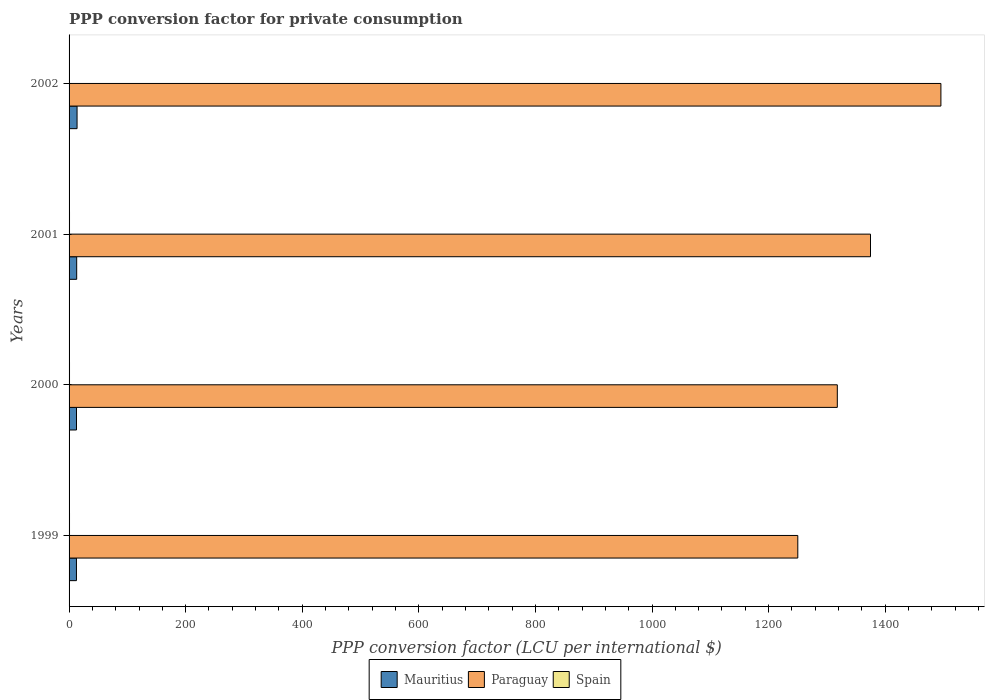How many different coloured bars are there?
Give a very brief answer. 3. Are the number of bars per tick equal to the number of legend labels?
Make the answer very short. Yes. How many bars are there on the 2nd tick from the top?
Ensure brevity in your answer.  3. How many bars are there on the 3rd tick from the bottom?
Your answer should be very brief. 3. What is the label of the 2nd group of bars from the top?
Provide a succinct answer. 2001. What is the PPP conversion factor for private consumption in Spain in 2001?
Your answer should be compact. 0.76. Across all years, what is the maximum PPP conversion factor for private consumption in Paraguay?
Provide a short and direct response. 1495.51. Across all years, what is the minimum PPP conversion factor for private consumption in Paraguay?
Provide a short and direct response. 1250.04. In which year was the PPP conversion factor for private consumption in Mauritius maximum?
Ensure brevity in your answer.  2002. What is the total PPP conversion factor for private consumption in Paraguay in the graph?
Provide a short and direct response. 5438.1. What is the difference between the PPP conversion factor for private consumption in Mauritius in 2000 and that in 2002?
Offer a terse response. -0.94. What is the difference between the PPP conversion factor for private consumption in Paraguay in 1999 and the PPP conversion factor for private consumption in Mauritius in 2002?
Offer a very short reply. 1236.34. What is the average PPP conversion factor for private consumption in Spain per year?
Offer a terse response. 0.76. In the year 1999, what is the difference between the PPP conversion factor for private consumption in Spain and PPP conversion factor for private consumption in Paraguay?
Ensure brevity in your answer.  -1249.27. What is the ratio of the PPP conversion factor for private consumption in Mauritius in 2000 to that in 2001?
Give a very brief answer. 0.98. Is the PPP conversion factor for private consumption in Spain in 1999 less than that in 2001?
Your answer should be compact. No. What is the difference between the highest and the second highest PPP conversion factor for private consumption in Spain?
Provide a short and direct response. 0. What is the difference between the highest and the lowest PPP conversion factor for private consumption in Spain?
Your answer should be compact. 0.02. In how many years, is the PPP conversion factor for private consumption in Spain greater than the average PPP conversion factor for private consumption in Spain taken over all years?
Offer a very short reply. 2. Is the sum of the PPP conversion factor for private consumption in Spain in 2001 and 2002 greater than the maximum PPP conversion factor for private consumption in Mauritius across all years?
Offer a terse response. No. What does the 3rd bar from the top in 2000 represents?
Ensure brevity in your answer.  Mauritius. What does the 2nd bar from the bottom in 2000 represents?
Your answer should be very brief. Paraguay. Is it the case that in every year, the sum of the PPP conversion factor for private consumption in Paraguay and PPP conversion factor for private consumption in Spain is greater than the PPP conversion factor for private consumption in Mauritius?
Your response must be concise. Yes. What is the difference between two consecutive major ticks on the X-axis?
Provide a short and direct response. 200. Are the values on the major ticks of X-axis written in scientific E-notation?
Give a very brief answer. No. How many legend labels are there?
Your answer should be compact. 3. How are the legend labels stacked?
Keep it short and to the point. Horizontal. What is the title of the graph?
Make the answer very short. PPP conversion factor for private consumption. Does "Bulgaria" appear as one of the legend labels in the graph?
Your answer should be compact. No. What is the label or title of the X-axis?
Make the answer very short. PPP conversion factor (LCU per international $). What is the PPP conversion factor (LCU per international $) in Mauritius in 1999?
Give a very brief answer. 12.65. What is the PPP conversion factor (LCU per international $) of Paraguay in 1999?
Offer a terse response. 1250.04. What is the PPP conversion factor (LCU per international $) in Spain in 1999?
Provide a short and direct response. 0.76. What is the PPP conversion factor (LCU per international $) of Mauritius in 2000?
Your response must be concise. 12.75. What is the PPP conversion factor (LCU per international $) in Paraguay in 2000?
Provide a succinct answer. 1317.81. What is the PPP conversion factor (LCU per international $) of Spain in 2000?
Your response must be concise. 0.76. What is the PPP conversion factor (LCU per international $) in Mauritius in 2001?
Ensure brevity in your answer.  13.07. What is the PPP conversion factor (LCU per international $) in Paraguay in 2001?
Provide a short and direct response. 1374.74. What is the PPP conversion factor (LCU per international $) in Spain in 2001?
Ensure brevity in your answer.  0.76. What is the PPP conversion factor (LCU per international $) in Mauritius in 2002?
Provide a short and direct response. 13.7. What is the PPP conversion factor (LCU per international $) in Paraguay in 2002?
Ensure brevity in your answer.  1495.51. What is the PPP conversion factor (LCU per international $) in Spain in 2002?
Ensure brevity in your answer.  0.75. Across all years, what is the maximum PPP conversion factor (LCU per international $) in Mauritius?
Make the answer very short. 13.7. Across all years, what is the maximum PPP conversion factor (LCU per international $) of Paraguay?
Your response must be concise. 1495.51. Across all years, what is the maximum PPP conversion factor (LCU per international $) of Spain?
Ensure brevity in your answer.  0.76. Across all years, what is the minimum PPP conversion factor (LCU per international $) of Mauritius?
Offer a terse response. 12.65. Across all years, what is the minimum PPP conversion factor (LCU per international $) of Paraguay?
Give a very brief answer. 1250.04. Across all years, what is the minimum PPP conversion factor (LCU per international $) of Spain?
Provide a short and direct response. 0.75. What is the total PPP conversion factor (LCU per international $) of Mauritius in the graph?
Offer a very short reply. 52.17. What is the total PPP conversion factor (LCU per international $) in Paraguay in the graph?
Your answer should be very brief. 5438.1. What is the total PPP conversion factor (LCU per international $) of Spain in the graph?
Make the answer very short. 3.03. What is the difference between the PPP conversion factor (LCU per international $) of Mauritius in 1999 and that in 2000?
Provide a succinct answer. -0.1. What is the difference between the PPP conversion factor (LCU per international $) in Paraguay in 1999 and that in 2000?
Your response must be concise. -67.78. What is the difference between the PPP conversion factor (LCU per international $) of Spain in 1999 and that in 2000?
Provide a short and direct response. 0. What is the difference between the PPP conversion factor (LCU per international $) of Mauritius in 1999 and that in 2001?
Your response must be concise. -0.42. What is the difference between the PPP conversion factor (LCU per international $) of Paraguay in 1999 and that in 2001?
Provide a short and direct response. -124.71. What is the difference between the PPP conversion factor (LCU per international $) in Spain in 1999 and that in 2001?
Your answer should be very brief. 0.01. What is the difference between the PPP conversion factor (LCU per international $) of Mauritius in 1999 and that in 2002?
Offer a terse response. -1.05. What is the difference between the PPP conversion factor (LCU per international $) of Paraguay in 1999 and that in 2002?
Keep it short and to the point. -245.48. What is the difference between the PPP conversion factor (LCU per international $) of Spain in 1999 and that in 2002?
Your answer should be compact. 0.02. What is the difference between the PPP conversion factor (LCU per international $) in Mauritius in 2000 and that in 2001?
Your response must be concise. -0.32. What is the difference between the PPP conversion factor (LCU per international $) of Paraguay in 2000 and that in 2001?
Offer a terse response. -56.93. What is the difference between the PPP conversion factor (LCU per international $) of Spain in 2000 and that in 2001?
Keep it short and to the point. 0. What is the difference between the PPP conversion factor (LCU per international $) of Mauritius in 2000 and that in 2002?
Your response must be concise. -0.94. What is the difference between the PPP conversion factor (LCU per international $) in Paraguay in 2000 and that in 2002?
Your response must be concise. -177.7. What is the difference between the PPP conversion factor (LCU per international $) in Spain in 2000 and that in 2002?
Your answer should be compact. 0.01. What is the difference between the PPP conversion factor (LCU per international $) in Mauritius in 2001 and that in 2002?
Your answer should be very brief. -0.63. What is the difference between the PPP conversion factor (LCU per international $) in Paraguay in 2001 and that in 2002?
Make the answer very short. -120.77. What is the difference between the PPP conversion factor (LCU per international $) of Spain in 2001 and that in 2002?
Offer a terse response. 0.01. What is the difference between the PPP conversion factor (LCU per international $) in Mauritius in 1999 and the PPP conversion factor (LCU per international $) in Paraguay in 2000?
Your answer should be very brief. -1305.16. What is the difference between the PPP conversion factor (LCU per international $) in Mauritius in 1999 and the PPP conversion factor (LCU per international $) in Spain in 2000?
Provide a short and direct response. 11.89. What is the difference between the PPP conversion factor (LCU per international $) in Paraguay in 1999 and the PPP conversion factor (LCU per international $) in Spain in 2000?
Your answer should be compact. 1249.27. What is the difference between the PPP conversion factor (LCU per international $) of Mauritius in 1999 and the PPP conversion factor (LCU per international $) of Paraguay in 2001?
Offer a terse response. -1362.09. What is the difference between the PPP conversion factor (LCU per international $) of Mauritius in 1999 and the PPP conversion factor (LCU per international $) of Spain in 2001?
Offer a terse response. 11.9. What is the difference between the PPP conversion factor (LCU per international $) of Paraguay in 1999 and the PPP conversion factor (LCU per international $) of Spain in 2001?
Keep it short and to the point. 1249.28. What is the difference between the PPP conversion factor (LCU per international $) of Mauritius in 1999 and the PPP conversion factor (LCU per international $) of Paraguay in 2002?
Make the answer very short. -1482.86. What is the difference between the PPP conversion factor (LCU per international $) of Mauritius in 1999 and the PPP conversion factor (LCU per international $) of Spain in 2002?
Make the answer very short. 11.9. What is the difference between the PPP conversion factor (LCU per international $) of Paraguay in 1999 and the PPP conversion factor (LCU per international $) of Spain in 2002?
Offer a terse response. 1249.29. What is the difference between the PPP conversion factor (LCU per international $) of Mauritius in 2000 and the PPP conversion factor (LCU per international $) of Paraguay in 2001?
Provide a succinct answer. -1361.99. What is the difference between the PPP conversion factor (LCU per international $) in Mauritius in 2000 and the PPP conversion factor (LCU per international $) in Spain in 2001?
Offer a terse response. 12. What is the difference between the PPP conversion factor (LCU per international $) of Paraguay in 2000 and the PPP conversion factor (LCU per international $) of Spain in 2001?
Make the answer very short. 1317.06. What is the difference between the PPP conversion factor (LCU per international $) of Mauritius in 2000 and the PPP conversion factor (LCU per international $) of Paraguay in 2002?
Your answer should be compact. -1482.76. What is the difference between the PPP conversion factor (LCU per international $) of Mauritius in 2000 and the PPP conversion factor (LCU per international $) of Spain in 2002?
Your answer should be compact. 12. What is the difference between the PPP conversion factor (LCU per international $) in Paraguay in 2000 and the PPP conversion factor (LCU per international $) in Spain in 2002?
Provide a succinct answer. 1317.07. What is the difference between the PPP conversion factor (LCU per international $) in Mauritius in 2001 and the PPP conversion factor (LCU per international $) in Paraguay in 2002?
Your answer should be very brief. -1482.44. What is the difference between the PPP conversion factor (LCU per international $) in Mauritius in 2001 and the PPP conversion factor (LCU per international $) in Spain in 2002?
Your answer should be compact. 12.32. What is the difference between the PPP conversion factor (LCU per international $) in Paraguay in 2001 and the PPP conversion factor (LCU per international $) in Spain in 2002?
Your answer should be compact. 1373.99. What is the average PPP conversion factor (LCU per international $) in Mauritius per year?
Keep it short and to the point. 13.04. What is the average PPP conversion factor (LCU per international $) in Paraguay per year?
Offer a very short reply. 1359.53. What is the average PPP conversion factor (LCU per international $) of Spain per year?
Your answer should be compact. 0.76. In the year 1999, what is the difference between the PPP conversion factor (LCU per international $) in Mauritius and PPP conversion factor (LCU per international $) in Paraguay?
Offer a very short reply. -1237.38. In the year 1999, what is the difference between the PPP conversion factor (LCU per international $) in Mauritius and PPP conversion factor (LCU per international $) in Spain?
Give a very brief answer. 11.89. In the year 1999, what is the difference between the PPP conversion factor (LCU per international $) in Paraguay and PPP conversion factor (LCU per international $) in Spain?
Keep it short and to the point. 1249.27. In the year 2000, what is the difference between the PPP conversion factor (LCU per international $) in Mauritius and PPP conversion factor (LCU per international $) in Paraguay?
Provide a short and direct response. -1305.06. In the year 2000, what is the difference between the PPP conversion factor (LCU per international $) in Mauritius and PPP conversion factor (LCU per international $) in Spain?
Keep it short and to the point. 11.99. In the year 2000, what is the difference between the PPP conversion factor (LCU per international $) of Paraguay and PPP conversion factor (LCU per international $) of Spain?
Keep it short and to the point. 1317.05. In the year 2001, what is the difference between the PPP conversion factor (LCU per international $) of Mauritius and PPP conversion factor (LCU per international $) of Paraguay?
Keep it short and to the point. -1361.67. In the year 2001, what is the difference between the PPP conversion factor (LCU per international $) in Mauritius and PPP conversion factor (LCU per international $) in Spain?
Your response must be concise. 12.31. In the year 2001, what is the difference between the PPP conversion factor (LCU per international $) in Paraguay and PPP conversion factor (LCU per international $) in Spain?
Offer a terse response. 1373.99. In the year 2002, what is the difference between the PPP conversion factor (LCU per international $) of Mauritius and PPP conversion factor (LCU per international $) of Paraguay?
Your response must be concise. -1481.81. In the year 2002, what is the difference between the PPP conversion factor (LCU per international $) of Mauritius and PPP conversion factor (LCU per international $) of Spain?
Your answer should be very brief. 12.95. In the year 2002, what is the difference between the PPP conversion factor (LCU per international $) of Paraguay and PPP conversion factor (LCU per international $) of Spain?
Provide a succinct answer. 1494.76. What is the ratio of the PPP conversion factor (LCU per international $) in Mauritius in 1999 to that in 2000?
Ensure brevity in your answer.  0.99. What is the ratio of the PPP conversion factor (LCU per international $) in Paraguay in 1999 to that in 2000?
Ensure brevity in your answer.  0.95. What is the ratio of the PPP conversion factor (LCU per international $) of Mauritius in 1999 to that in 2001?
Keep it short and to the point. 0.97. What is the ratio of the PPP conversion factor (LCU per international $) in Paraguay in 1999 to that in 2001?
Provide a succinct answer. 0.91. What is the ratio of the PPP conversion factor (LCU per international $) in Spain in 1999 to that in 2001?
Provide a succinct answer. 1.01. What is the ratio of the PPP conversion factor (LCU per international $) in Mauritius in 1999 to that in 2002?
Offer a very short reply. 0.92. What is the ratio of the PPP conversion factor (LCU per international $) of Paraguay in 1999 to that in 2002?
Make the answer very short. 0.84. What is the ratio of the PPP conversion factor (LCU per international $) of Spain in 1999 to that in 2002?
Offer a terse response. 1.02. What is the ratio of the PPP conversion factor (LCU per international $) in Mauritius in 2000 to that in 2001?
Your response must be concise. 0.98. What is the ratio of the PPP conversion factor (LCU per international $) of Paraguay in 2000 to that in 2001?
Give a very brief answer. 0.96. What is the ratio of the PPP conversion factor (LCU per international $) of Spain in 2000 to that in 2001?
Your answer should be compact. 1.01. What is the ratio of the PPP conversion factor (LCU per international $) in Mauritius in 2000 to that in 2002?
Offer a very short reply. 0.93. What is the ratio of the PPP conversion factor (LCU per international $) of Paraguay in 2000 to that in 2002?
Your answer should be compact. 0.88. What is the ratio of the PPP conversion factor (LCU per international $) of Spain in 2000 to that in 2002?
Offer a very short reply. 1.02. What is the ratio of the PPP conversion factor (LCU per international $) of Mauritius in 2001 to that in 2002?
Provide a short and direct response. 0.95. What is the ratio of the PPP conversion factor (LCU per international $) in Paraguay in 2001 to that in 2002?
Provide a short and direct response. 0.92. What is the ratio of the PPP conversion factor (LCU per international $) of Spain in 2001 to that in 2002?
Provide a short and direct response. 1.01. What is the difference between the highest and the second highest PPP conversion factor (LCU per international $) of Mauritius?
Ensure brevity in your answer.  0.63. What is the difference between the highest and the second highest PPP conversion factor (LCU per international $) of Paraguay?
Offer a very short reply. 120.77. What is the difference between the highest and the second highest PPP conversion factor (LCU per international $) of Spain?
Give a very brief answer. 0. What is the difference between the highest and the lowest PPP conversion factor (LCU per international $) of Mauritius?
Your answer should be very brief. 1.05. What is the difference between the highest and the lowest PPP conversion factor (LCU per international $) in Paraguay?
Your response must be concise. 245.48. What is the difference between the highest and the lowest PPP conversion factor (LCU per international $) of Spain?
Your answer should be compact. 0.02. 